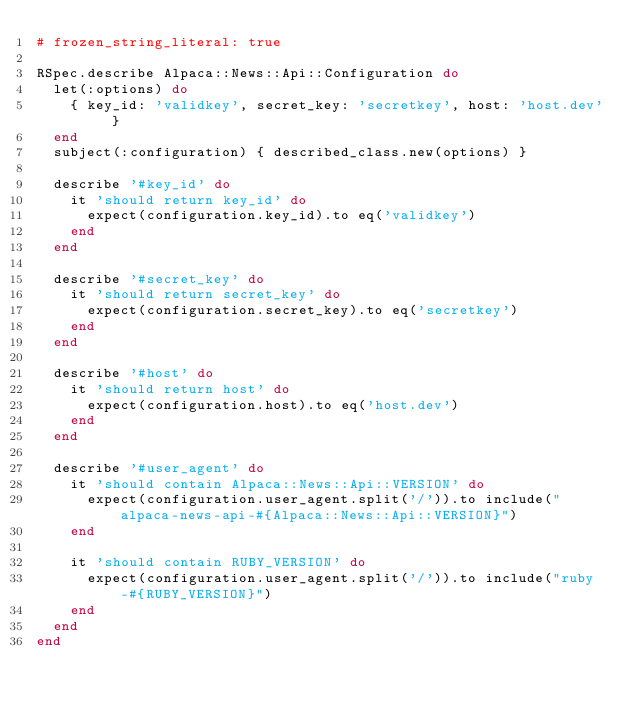Convert code to text. <code><loc_0><loc_0><loc_500><loc_500><_Ruby_># frozen_string_literal: true

RSpec.describe Alpaca::News::Api::Configuration do
  let(:options) do
    { key_id: 'validkey', secret_key: 'secretkey', host: 'host.dev' }
  end
  subject(:configuration) { described_class.new(options) }

  describe '#key_id' do
    it 'should return key_id' do
      expect(configuration.key_id).to eq('validkey')
    end
  end

  describe '#secret_key' do
    it 'should return secret_key' do
      expect(configuration.secret_key).to eq('secretkey')
    end
  end

  describe '#host' do
    it 'should return host' do
      expect(configuration.host).to eq('host.dev')
    end
  end

  describe '#user_agent' do
    it 'should contain Alpaca::News::Api::VERSION' do
      expect(configuration.user_agent.split('/')).to include("alpaca-news-api-#{Alpaca::News::Api::VERSION}")
    end

    it 'should contain RUBY_VERSION' do
      expect(configuration.user_agent.split('/')).to include("ruby-#{RUBY_VERSION}")
    end
  end
end
</code> 